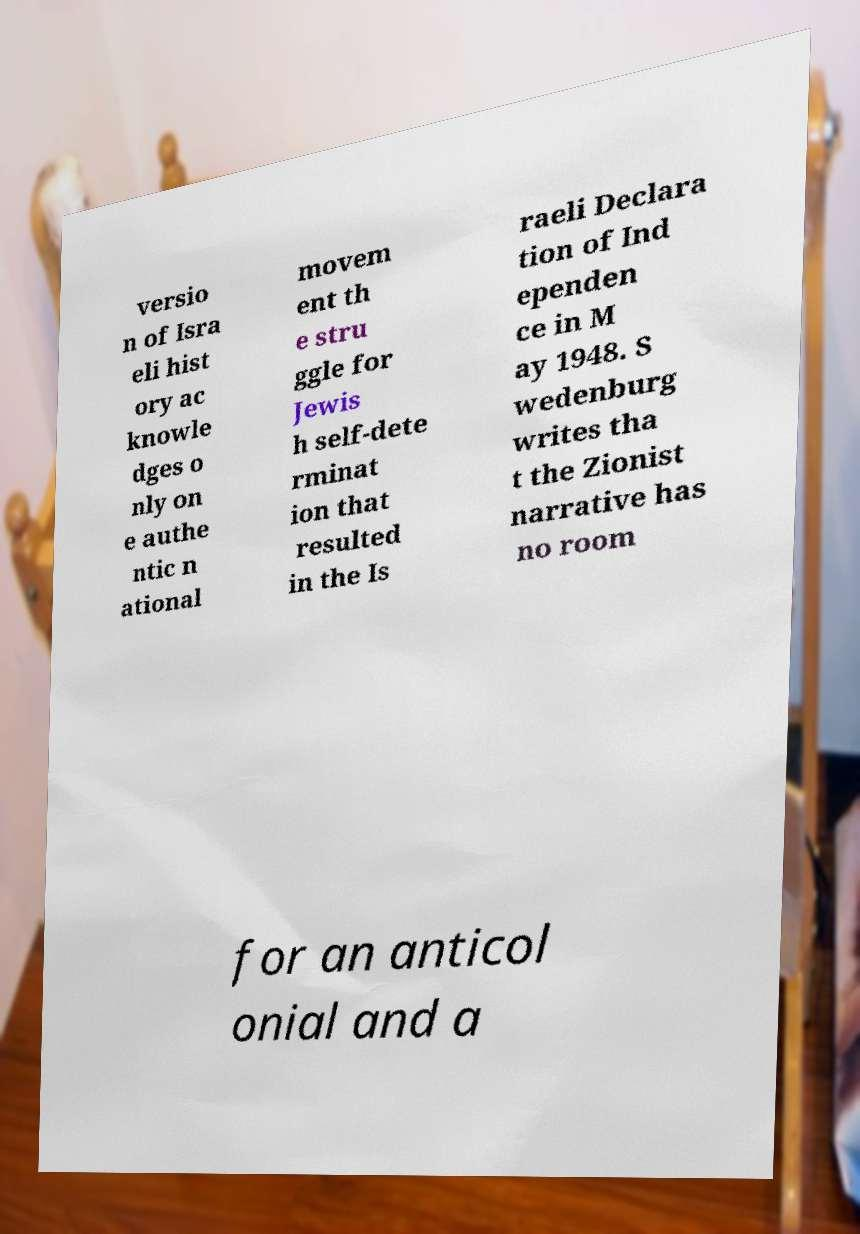Please read and relay the text visible in this image. What does it say? versio n of Isra eli hist ory ac knowle dges o nly on e authe ntic n ational movem ent th e stru ggle for Jewis h self-dete rminat ion that resulted in the Is raeli Declara tion of Ind ependen ce in M ay 1948. S wedenburg writes tha t the Zionist narrative has no room for an anticol onial and a 